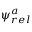Convert formula to latex. <formula><loc_0><loc_0><loc_500><loc_500>\psi _ { r e l } ^ { a }</formula> 